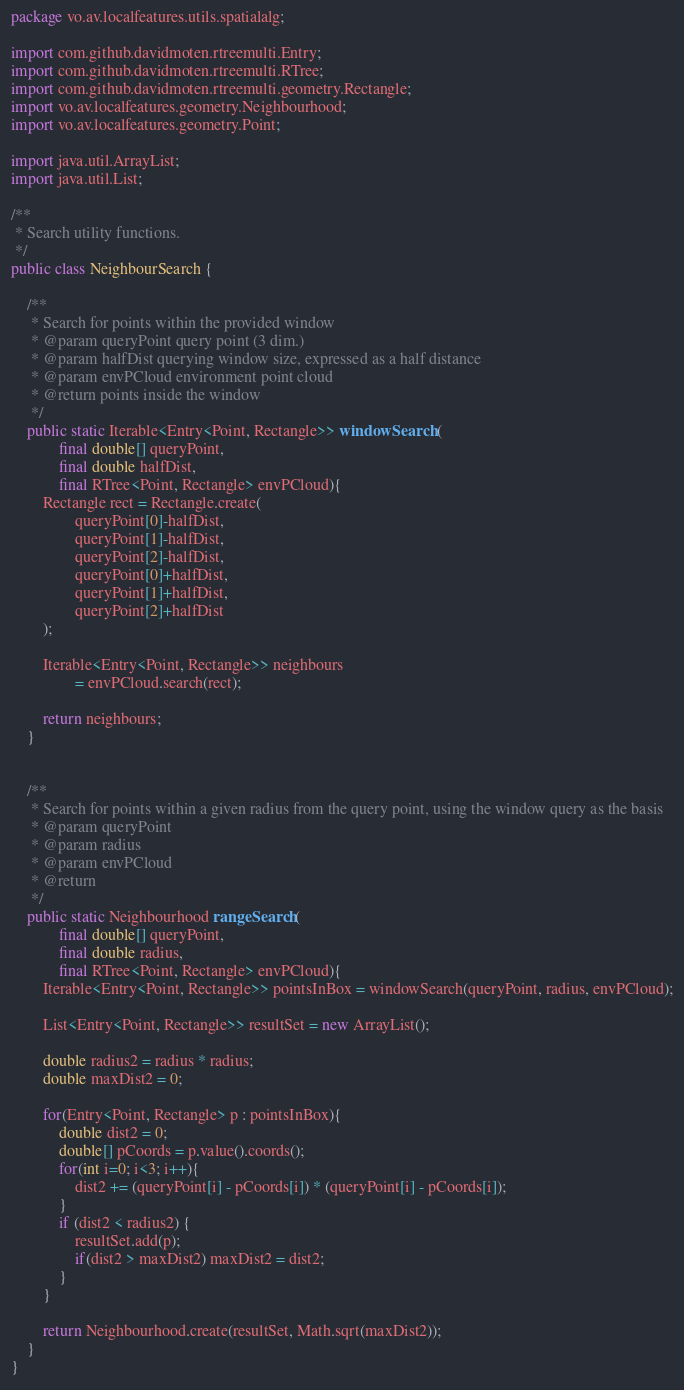Convert code to text. <code><loc_0><loc_0><loc_500><loc_500><_Java_>package vo.av.localfeatures.utils.spatialalg;

import com.github.davidmoten.rtreemulti.Entry;
import com.github.davidmoten.rtreemulti.RTree;
import com.github.davidmoten.rtreemulti.geometry.Rectangle;
import vo.av.localfeatures.geometry.Neighbourhood;
import vo.av.localfeatures.geometry.Point;

import java.util.ArrayList;
import java.util.List;

/**
 * Search utility functions.
 */
public class NeighbourSearch {

    /**
     * Search for points within the provided window
     * @param queryPoint query point (3 dim.)
     * @param halfDist querying window size, expressed as a half distance
     * @param envPCloud environment point cloud
     * @return points inside the window
     */
    public static Iterable<Entry<Point, Rectangle>> windowSearch (
            final double[] queryPoint,
            final double halfDist,
            final RTree<Point, Rectangle> envPCloud){
        Rectangle rect = Rectangle.create(
                queryPoint[0]-halfDist,
                queryPoint[1]-halfDist,
                queryPoint[2]-halfDist,
                queryPoint[0]+halfDist,
                queryPoint[1]+halfDist,
                queryPoint[2]+halfDist
        );

        Iterable<Entry<Point, Rectangle>> neighbours
                = envPCloud.search(rect);

        return neighbours;
    }


    /**
     * Search for points within a given radius from the query point, using the window query as the basis
     * @param queryPoint
     * @param radius
     * @param envPCloud
     * @return
     */
    public static Neighbourhood rangeSearch (
            final double[] queryPoint,
            final double radius,
            final RTree<Point, Rectangle> envPCloud){
        Iterable<Entry<Point, Rectangle>> pointsInBox = windowSearch(queryPoint, radius, envPCloud);

        List<Entry<Point, Rectangle>> resultSet = new ArrayList();

        double radius2 = radius * radius;
        double maxDist2 = 0;

        for(Entry<Point, Rectangle> p : pointsInBox){
            double dist2 = 0;
            double[] pCoords = p.value().coords();
            for(int i=0; i<3; i++){
                dist2 += (queryPoint[i] - pCoords[i]) * (queryPoint[i] - pCoords[i]);
            }
            if (dist2 < radius2) {
                resultSet.add(p);
                if(dist2 > maxDist2) maxDist2 = dist2;
            }
        }

        return Neighbourhood.create(resultSet, Math.sqrt(maxDist2));
    }
}
</code> 